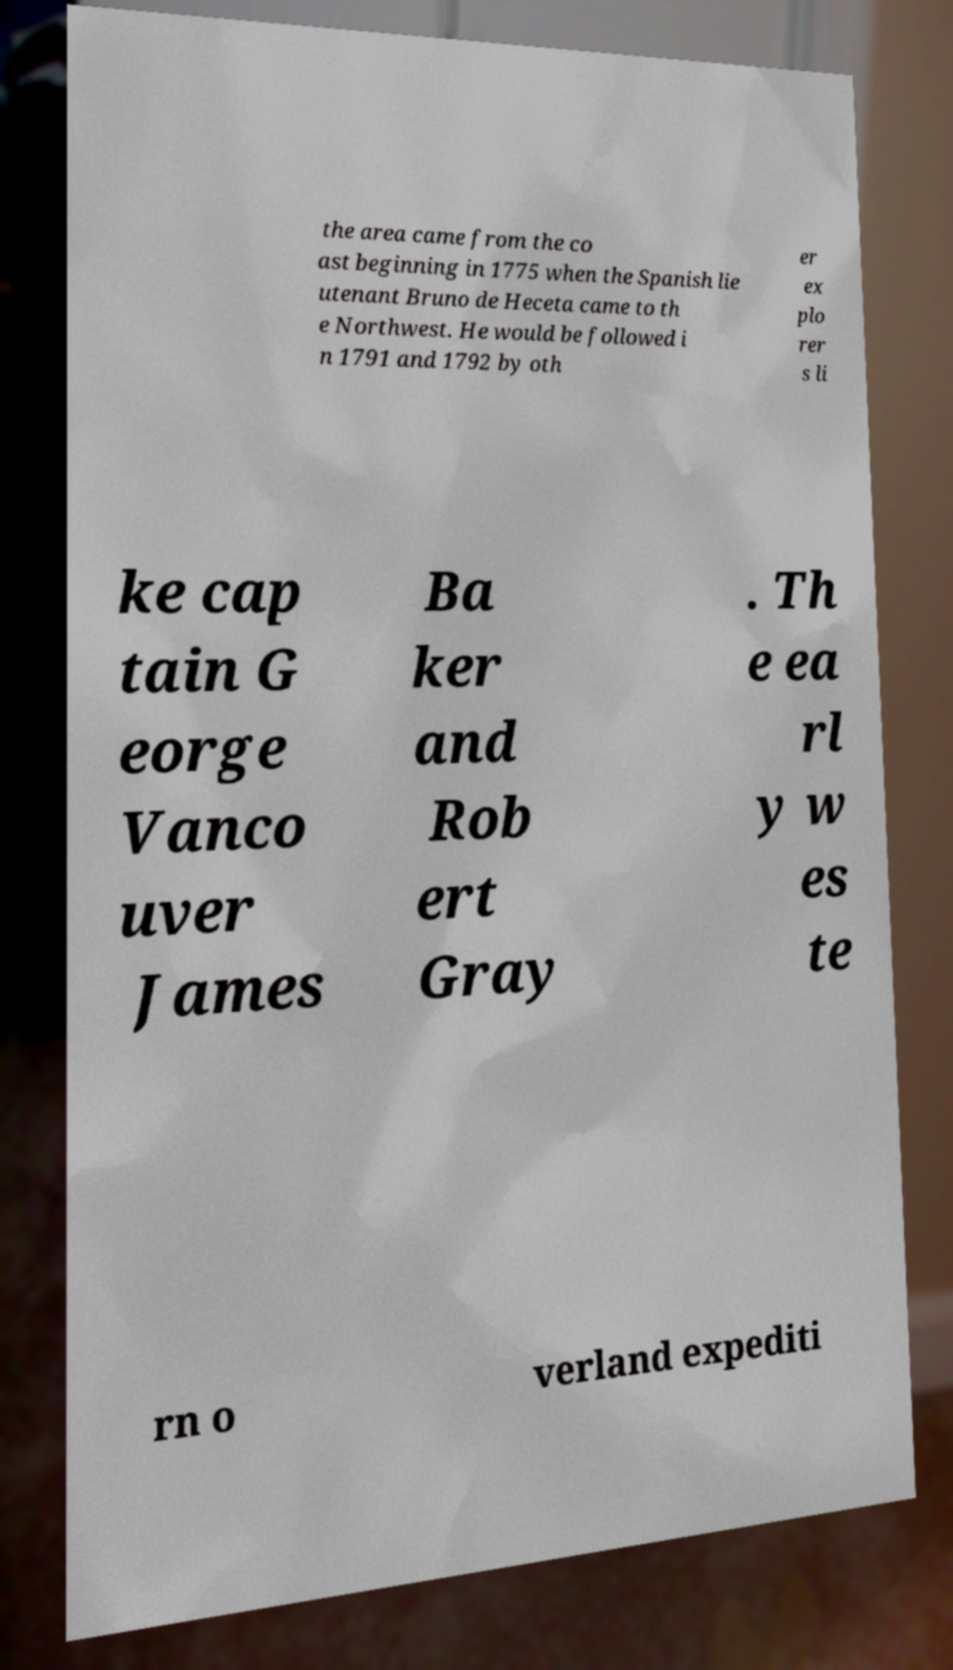For documentation purposes, I need the text within this image transcribed. Could you provide that? the area came from the co ast beginning in 1775 when the Spanish lie utenant Bruno de Heceta came to th e Northwest. He would be followed i n 1791 and 1792 by oth er ex plo rer s li ke cap tain G eorge Vanco uver James Ba ker and Rob ert Gray . Th e ea rl y w es te rn o verland expediti 